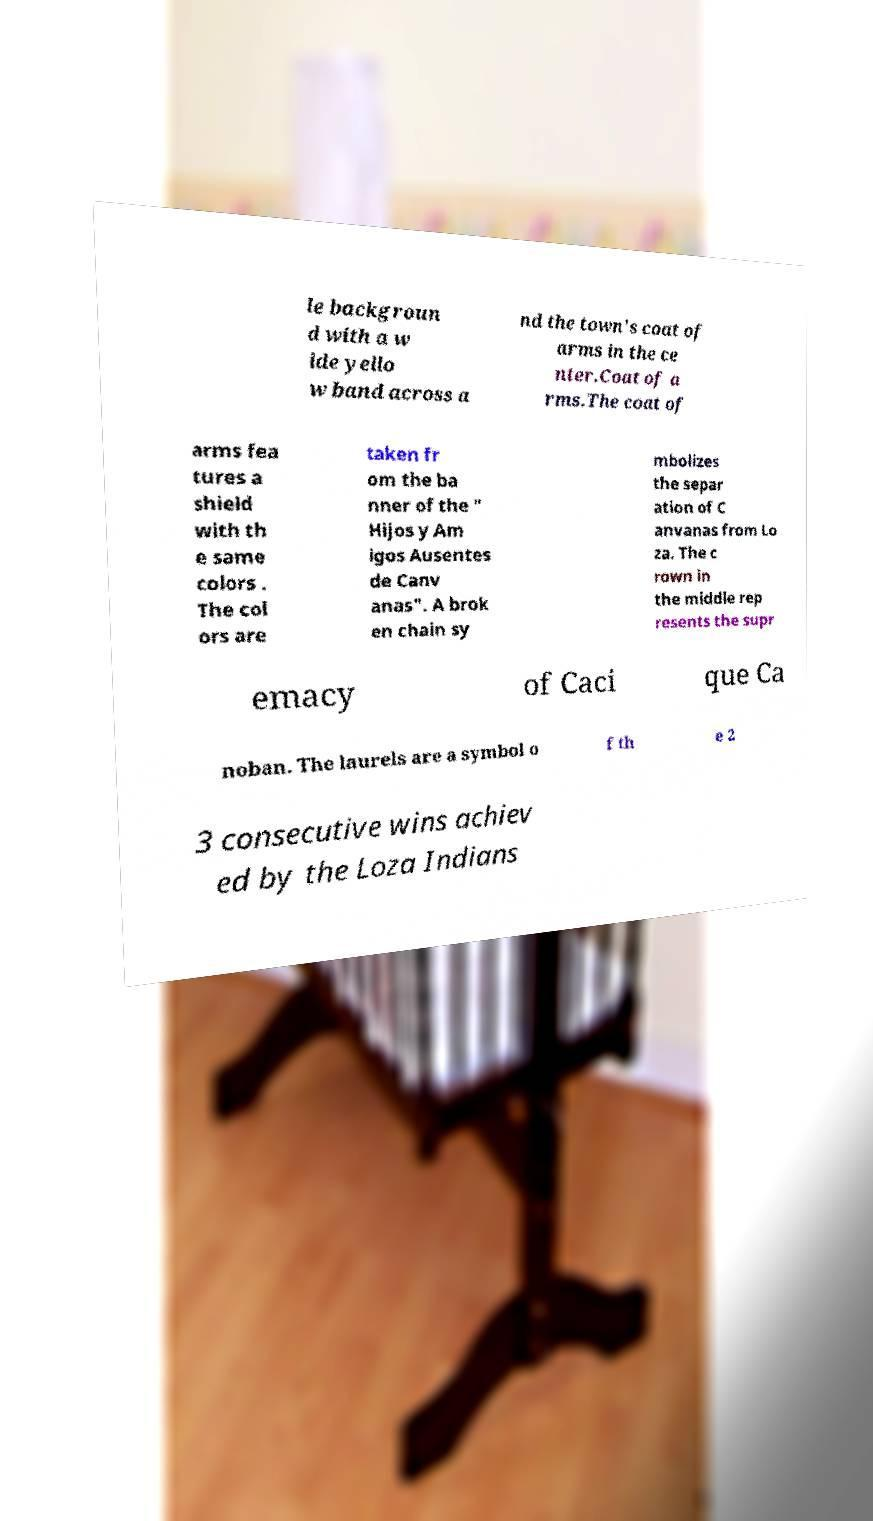For documentation purposes, I need the text within this image transcribed. Could you provide that? le backgroun d with a w ide yello w band across a nd the town's coat of arms in the ce nter.Coat of a rms.The coat of arms fea tures a shield with th e same colors . The col ors are taken fr om the ba nner of the " Hijos y Am igos Ausentes de Canv anas". A brok en chain sy mbolizes the separ ation of C anvanas from Lo za. The c rown in the middle rep resents the supr emacy of Caci que Ca noban. The laurels are a symbol o f th e 2 3 consecutive wins achiev ed by the Loza Indians 